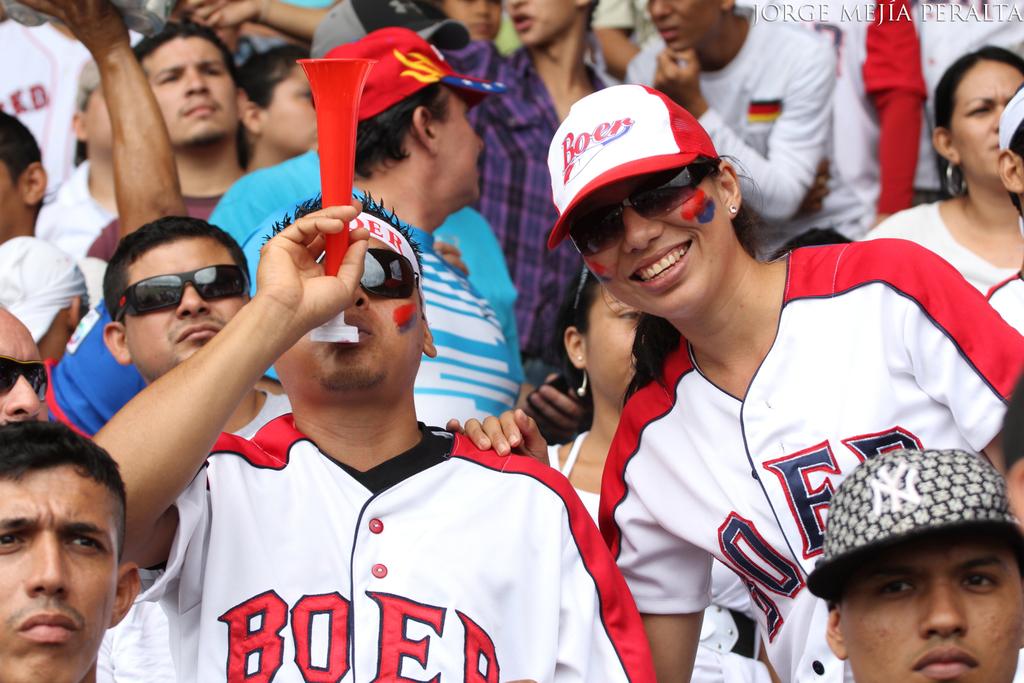What does his jersey say?
Provide a succinct answer. Boer. 